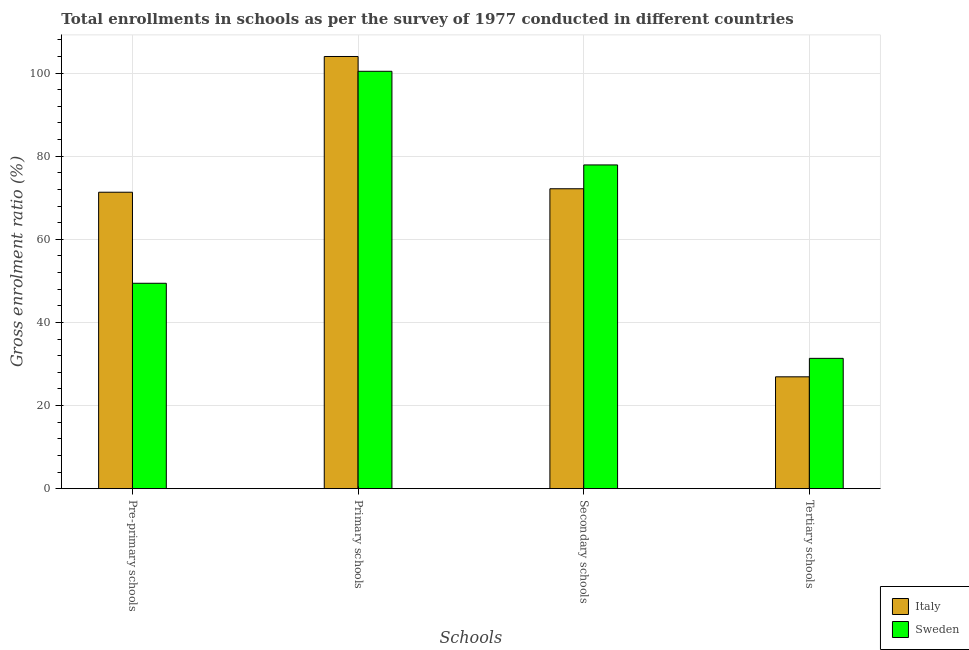Are the number of bars per tick equal to the number of legend labels?
Offer a terse response. Yes. Are the number of bars on each tick of the X-axis equal?
Keep it short and to the point. Yes. How many bars are there on the 1st tick from the right?
Your answer should be compact. 2. What is the label of the 4th group of bars from the left?
Your response must be concise. Tertiary schools. What is the gross enrolment ratio in secondary schools in Italy?
Offer a very short reply. 72.16. Across all countries, what is the maximum gross enrolment ratio in pre-primary schools?
Your answer should be very brief. 71.32. Across all countries, what is the minimum gross enrolment ratio in pre-primary schools?
Make the answer very short. 49.42. In which country was the gross enrolment ratio in secondary schools maximum?
Your answer should be very brief. Sweden. What is the total gross enrolment ratio in primary schools in the graph?
Provide a short and direct response. 204.41. What is the difference between the gross enrolment ratio in tertiary schools in Sweden and that in Italy?
Make the answer very short. 4.44. What is the difference between the gross enrolment ratio in tertiary schools in Italy and the gross enrolment ratio in secondary schools in Sweden?
Keep it short and to the point. -50.98. What is the average gross enrolment ratio in pre-primary schools per country?
Your response must be concise. 60.37. What is the difference between the gross enrolment ratio in pre-primary schools and gross enrolment ratio in tertiary schools in Italy?
Make the answer very short. 44.41. What is the ratio of the gross enrolment ratio in secondary schools in Italy to that in Sweden?
Make the answer very short. 0.93. Is the gross enrolment ratio in tertiary schools in Italy less than that in Sweden?
Ensure brevity in your answer.  Yes. What is the difference between the highest and the second highest gross enrolment ratio in tertiary schools?
Make the answer very short. 4.44. What is the difference between the highest and the lowest gross enrolment ratio in tertiary schools?
Keep it short and to the point. 4.44. How many bars are there?
Give a very brief answer. 8. Are all the bars in the graph horizontal?
Your response must be concise. No. What is the difference between two consecutive major ticks on the Y-axis?
Provide a short and direct response. 20. Are the values on the major ticks of Y-axis written in scientific E-notation?
Your answer should be compact. No. How many legend labels are there?
Ensure brevity in your answer.  2. What is the title of the graph?
Make the answer very short. Total enrollments in schools as per the survey of 1977 conducted in different countries. What is the label or title of the X-axis?
Provide a succinct answer. Schools. What is the Gross enrolment ratio (%) of Italy in Pre-primary schools?
Your response must be concise. 71.32. What is the Gross enrolment ratio (%) in Sweden in Pre-primary schools?
Keep it short and to the point. 49.42. What is the Gross enrolment ratio (%) of Italy in Primary schools?
Offer a terse response. 103.98. What is the Gross enrolment ratio (%) in Sweden in Primary schools?
Provide a succinct answer. 100.42. What is the Gross enrolment ratio (%) of Italy in Secondary schools?
Keep it short and to the point. 72.16. What is the Gross enrolment ratio (%) of Sweden in Secondary schools?
Ensure brevity in your answer.  77.89. What is the Gross enrolment ratio (%) of Italy in Tertiary schools?
Make the answer very short. 26.91. What is the Gross enrolment ratio (%) of Sweden in Tertiary schools?
Provide a short and direct response. 31.35. Across all Schools, what is the maximum Gross enrolment ratio (%) of Italy?
Offer a very short reply. 103.98. Across all Schools, what is the maximum Gross enrolment ratio (%) of Sweden?
Ensure brevity in your answer.  100.42. Across all Schools, what is the minimum Gross enrolment ratio (%) of Italy?
Your response must be concise. 26.91. Across all Schools, what is the minimum Gross enrolment ratio (%) in Sweden?
Your answer should be very brief. 31.35. What is the total Gross enrolment ratio (%) in Italy in the graph?
Your answer should be very brief. 274.38. What is the total Gross enrolment ratio (%) in Sweden in the graph?
Ensure brevity in your answer.  259.09. What is the difference between the Gross enrolment ratio (%) of Italy in Pre-primary schools and that in Primary schools?
Your answer should be compact. -32.66. What is the difference between the Gross enrolment ratio (%) in Sweden in Pre-primary schools and that in Primary schools?
Your answer should be very brief. -51. What is the difference between the Gross enrolment ratio (%) of Italy in Pre-primary schools and that in Secondary schools?
Offer a very short reply. -0.84. What is the difference between the Gross enrolment ratio (%) in Sweden in Pre-primary schools and that in Secondary schools?
Ensure brevity in your answer.  -28.47. What is the difference between the Gross enrolment ratio (%) of Italy in Pre-primary schools and that in Tertiary schools?
Your answer should be compact. 44.41. What is the difference between the Gross enrolment ratio (%) in Sweden in Pre-primary schools and that in Tertiary schools?
Provide a succinct answer. 18.07. What is the difference between the Gross enrolment ratio (%) in Italy in Primary schools and that in Secondary schools?
Offer a very short reply. 31.82. What is the difference between the Gross enrolment ratio (%) in Sweden in Primary schools and that in Secondary schools?
Make the answer very short. 22.53. What is the difference between the Gross enrolment ratio (%) in Italy in Primary schools and that in Tertiary schools?
Make the answer very short. 77.07. What is the difference between the Gross enrolment ratio (%) of Sweden in Primary schools and that in Tertiary schools?
Offer a very short reply. 69.07. What is the difference between the Gross enrolment ratio (%) of Italy in Secondary schools and that in Tertiary schools?
Provide a succinct answer. 45.25. What is the difference between the Gross enrolment ratio (%) in Sweden in Secondary schools and that in Tertiary schools?
Offer a terse response. 46.54. What is the difference between the Gross enrolment ratio (%) of Italy in Pre-primary schools and the Gross enrolment ratio (%) of Sweden in Primary schools?
Provide a short and direct response. -29.1. What is the difference between the Gross enrolment ratio (%) of Italy in Pre-primary schools and the Gross enrolment ratio (%) of Sweden in Secondary schools?
Offer a very short reply. -6.57. What is the difference between the Gross enrolment ratio (%) in Italy in Pre-primary schools and the Gross enrolment ratio (%) in Sweden in Tertiary schools?
Your answer should be compact. 39.97. What is the difference between the Gross enrolment ratio (%) of Italy in Primary schools and the Gross enrolment ratio (%) of Sweden in Secondary schools?
Your answer should be compact. 26.09. What is the difference between the Gross enrolment ratio (%) in Italy in Primary schools and the Gross enrolment ratio (%) in Sweden in Tertiary schools?
Give a very brief answer. 72.63. What is the difference between the Gross enrolment ratio (%) in Italy in Secondary schools and the Gross enrolment ratio (%) in Sweden in Tertiary schools?
Make the answer very short. 40.8. What is the average Gross enrolment ratio (%) in Italy per Schools?
Make the answer very short. 68.59. What is the average Gross enrolment ratio (%) in Sweden per Schools?
Provide a short and direct response. 64.77. What is the difference between the Gross enrolment ratio (%) of Italy and Gross enrolment ratio (%) of Sweden in Pre-primary schools?
Your response must be concise. 21.9. What is the difference between the Gross enrolment ratio (%) in Italy and Gross enrolment ratio (%) in Sweden in Primary schools?
Offer a very short reply. 3.56. What is the difference between the Gross enrolment ratio (%) in Italy and Gross enrolment ratio (%) in Sweden in Secondary schools?
Make the answer very short. -5.73. What is the difference between the Gross enrolment ratio (%) in Italy and Gross enrolment ratio (%) in Sweden in Tertiary schools?
Your response must be concise. -4.44. What is the ratio of the Gross enrolment ratio (%) in Italy in Pre-primary schools to that in Primary schools?
Offer a terse response. 0.69. What is the ratio of the Gross enrolment ratio (%) in Sweden in Pre-primary schools to that in Primary schools?
Your response must be concise. 0.49. What is the ratio of the Gross enrolment ratio (%) of Italy in Pre-primary schools to that in Secondary schools?
Offer a terse response. 0.99. What is the ratio of the Gross enrolment ratio (%) of Sweden in Pre-primary schools to that in Secondary schools?
Keep it short and to the point. 0.63. What is the ratio of the Gross enrolment ratio (%) of Italy in Pre-primary schools to that in Tertiary schools?
Your answer should be compact. 2.65. What is the ratio of the Gross enrolment ratio (%) in Sweden in Pre-primary schools to that in Tertiary schools?
Make the answer very short. 1.58. What is the ratio of the Gross enrolment ratio (%) of Italy in Primary schools to that in Secondary schools?
Provide a succinct answer. 1.44. What is the ratio of the Gross enrolment ratio (%) in Sweden in Primary schools to that in Secondary schools?
Give a very brief answer. 1.29. What is the ratio of the Gross enrolment ratio (%) in Italy in Primary schools to that in Tertiary schools?
Keep it short and to the point. 3.86. What is the ratio of the Gross enrolment ratio (%) of Sweden in Primary schools to that in Tertiary schools?
Give a very brief answer. 3.2. What is the ratio of the Gross enrolment ratio (%) of Italy in Secondary schools to that in Tertiary schools?
Your response must be concise. 2.68. What is the ratio of the Gross enrolment ratio (%) in Sweden in Secondary schools to that in Tertiary schools?
Make the answer very short. 2.48. What is the difference between the highest and the second highest Gross enrolment ratio (%) of Italy?
Your response must be concise. 31.82. What is the difference between the highest and the second highest Gross enrolment ratio (%) of Sweden?
Your answer should be very brief. 22.53. What is the difference between the highest and the lowest Gross enrolment ratio (%) in Italy?
Make the answer very short. 77.07. What is the difference between the highest and the lowest Gross enrolment ratio (%) of Sweden?
Ensure brevity in your answer.  69.07. 